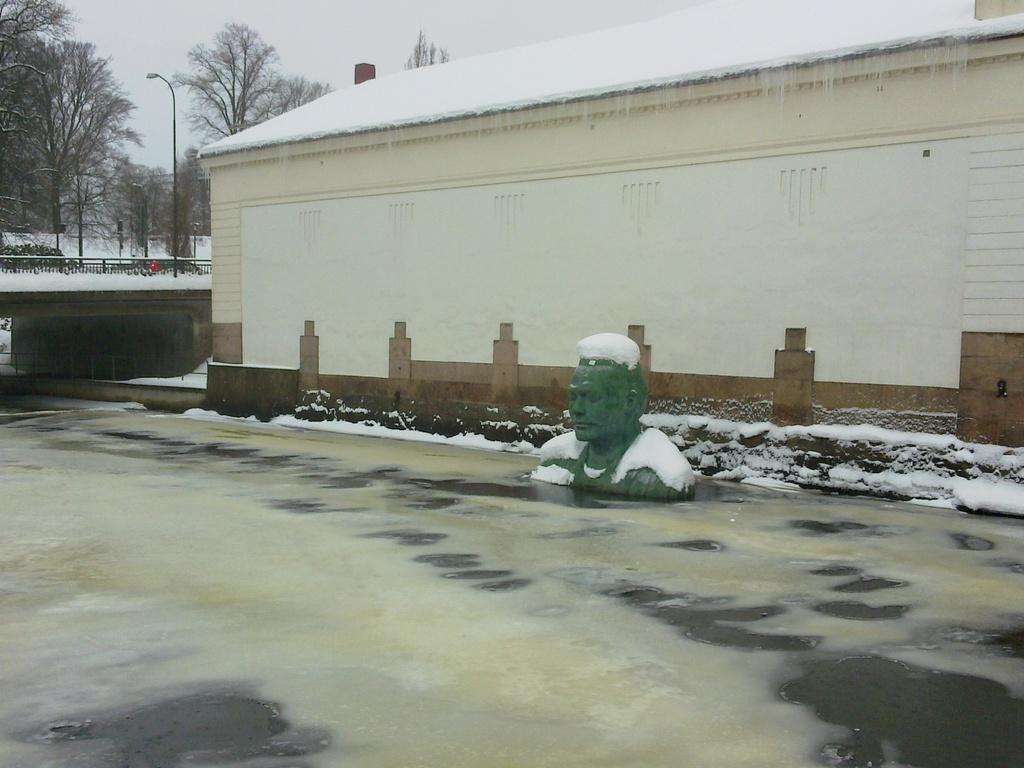Describe this image in one or two sentences. This picture is clicked outside. On the right we can see a sculpture of a person and a house and we can see the snow on the roof of the house. In the background there is a sky, trees, poles and a bridge and a lot of snow. 